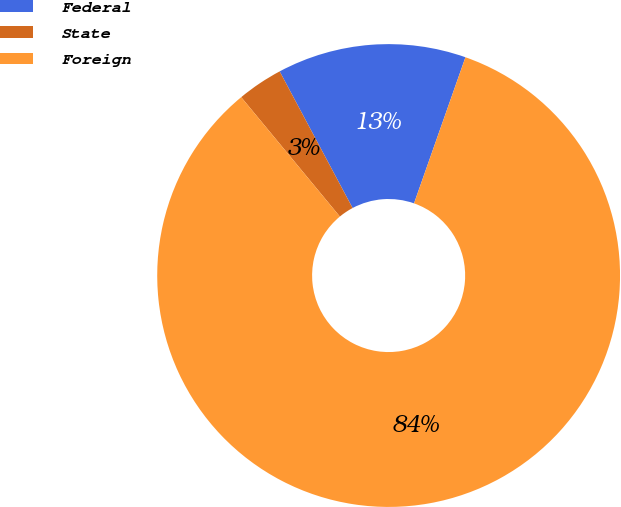<chart> <loc_0><loc_0><loc_500><loc_500><pie_chart><fcel>Federal<fcel>State<fcel>Foreign<nl><fcel>13.19%<fcel>3.19%<fcel>83.62%<nl></chart> 